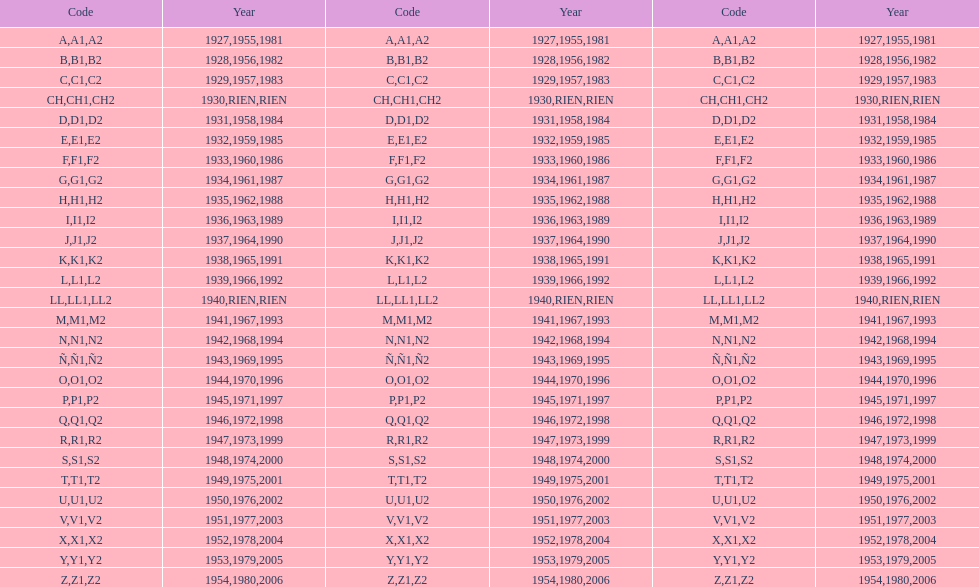Number of codes containing a 2? 28. 